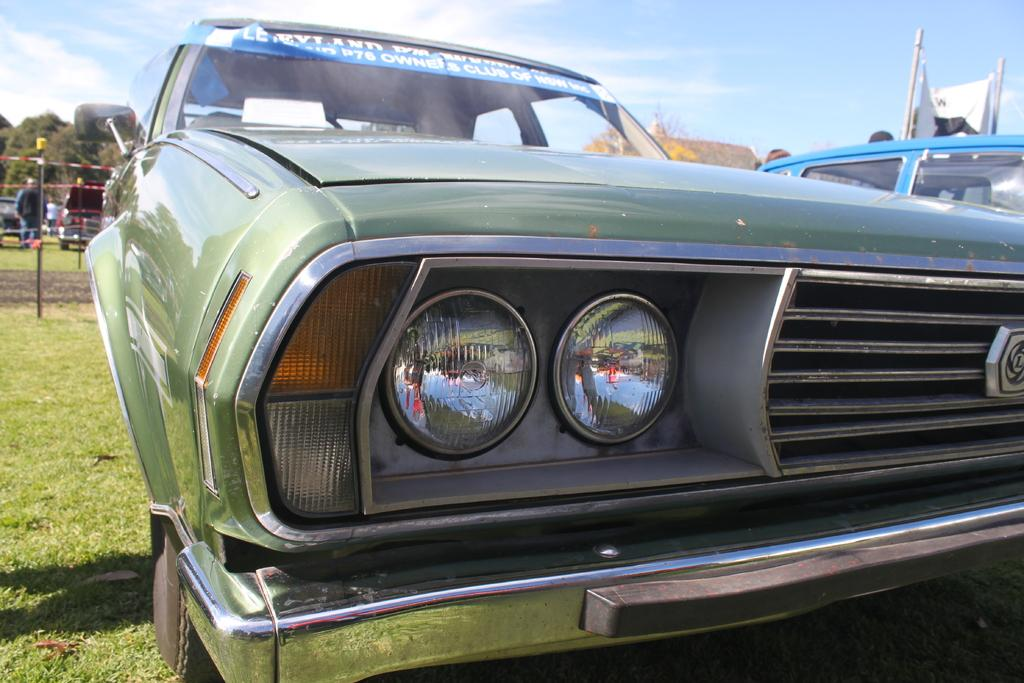What can be seen in the sky in the image? The sky with clouds is visible in the image. What type of natural vegetation is present in the image? There are trees in the image. What are the tall, thin structures in the image? There are poles in the image. Who or what is present on the ground in the image? There are persons and motor vehicles present on the ground in the image. What type of vegetable is being served on a tray in the image? There is no tray or vegetable present in the image; it features the sky, trees, poles, persons, and motor vehicles. 